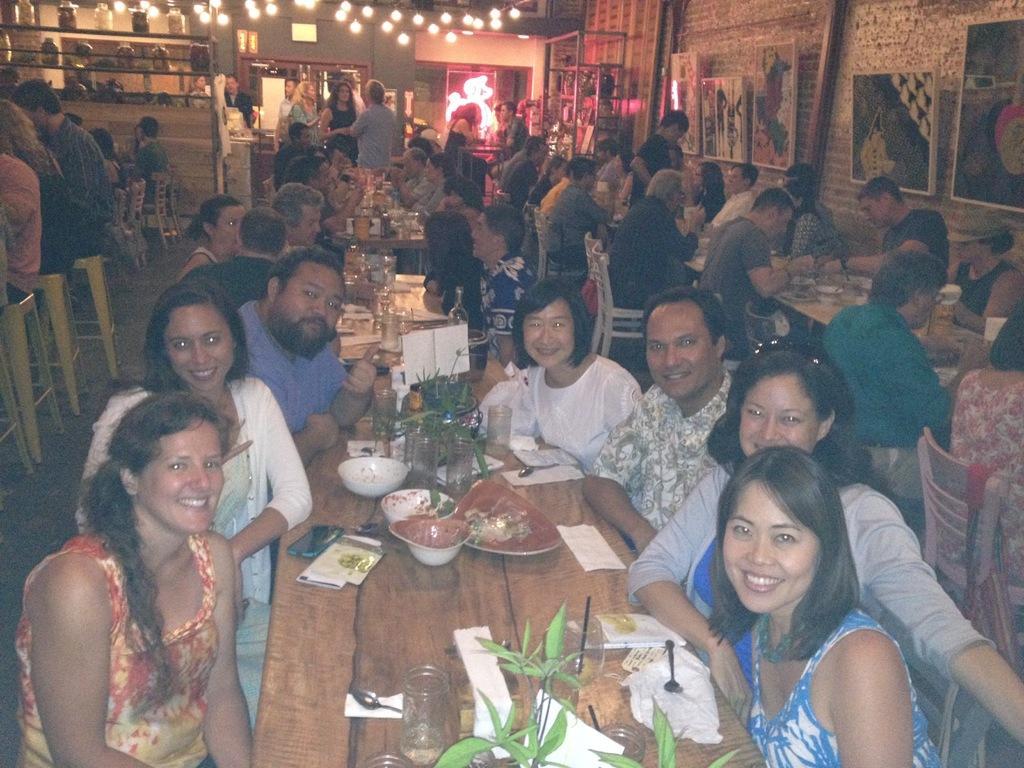Please provide a concise description of this image. In this image I can see the group few people with different color dresses. I can see few people are sitting in-front of the table and few people are standing. On the tables I can see the plates and bowls with food, glasses, flowers pots, spoons, tissues and many objects. To the right I can see the boards to the wall. In the background I can see few more boards and the lights. 